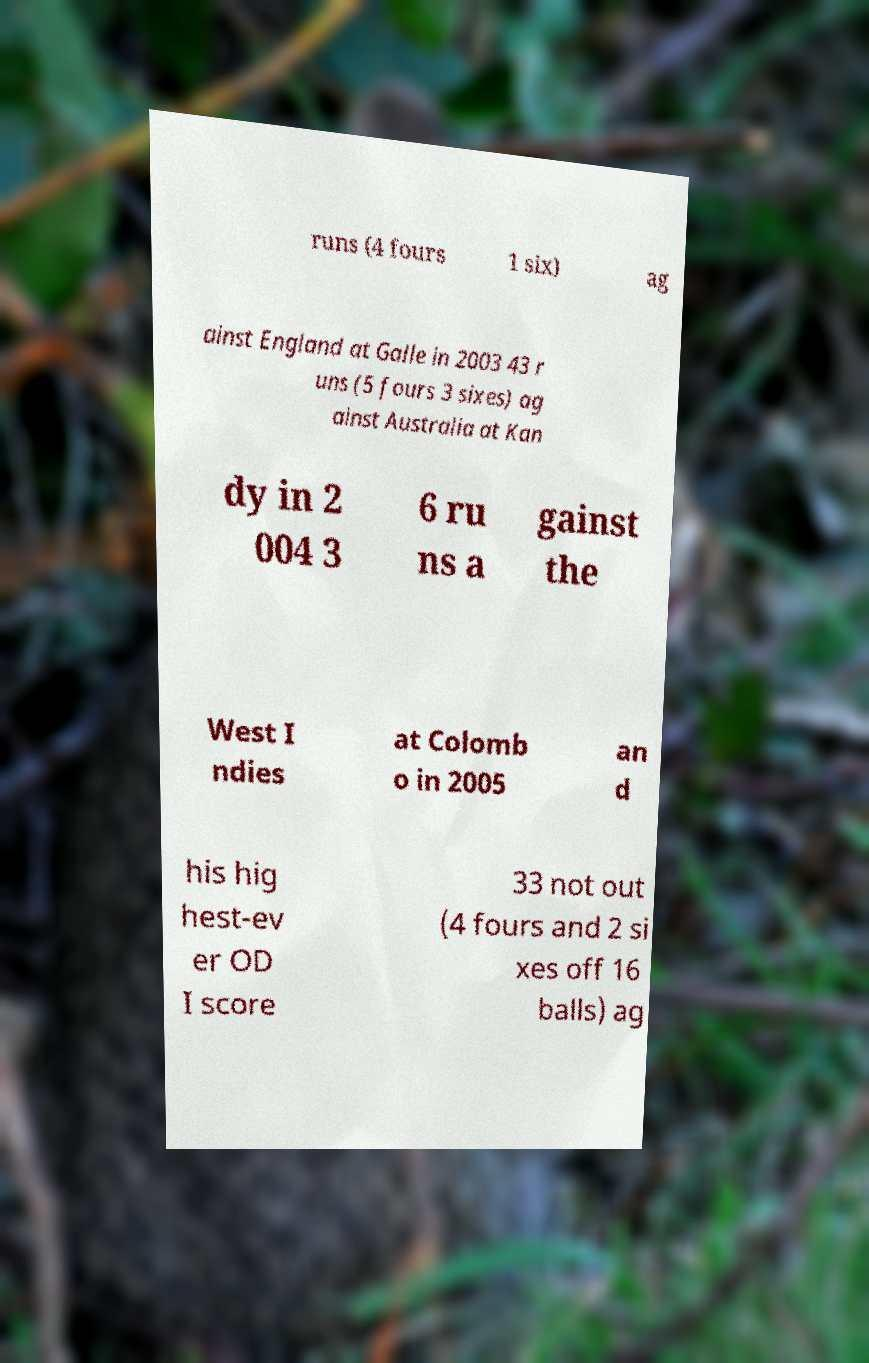For documentation purposes, I need the text within this image transcribed. Could you provide that? runs (4 fours 1 six) ag ainst England at Galle in 2003 43 r uns (5 fours 3 sixes) ag ainst Australia at Kan dy in 2 004 3 6 ru ns a gainst the West I ndies at Colomb o in 2005 an d his hig hest-ev er OD I score 33 not out (4 fours and 2 si xes off 16 balls) ag 